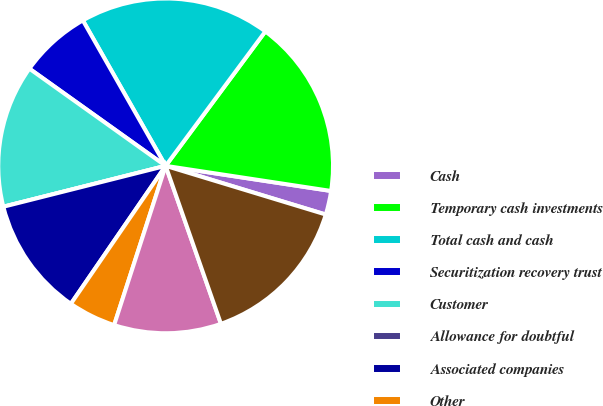<chart> <loc_0><loc_0><loc_500><loc_500><pie_chart><fcel>Cash<fcel>Temporary cash investments<fcel>Total cash and cash<fcel>Securitization recovery trust<fcel>Customer<fcel>Allowance for doubtful<fcel>Associated companies<fcel>Other<fcel>Accrued unbilled revenues<fcel>Total accounts receivable<nl><fcel>2.3%<fcel>17.24%<fcel>18.39%<fcel>6.9%<fcel>13.79%<fcel>0.0%<fcel>11.49%<fcel>4.6%<fcel>10.34%<fcel>14.94%<nl></chart> 